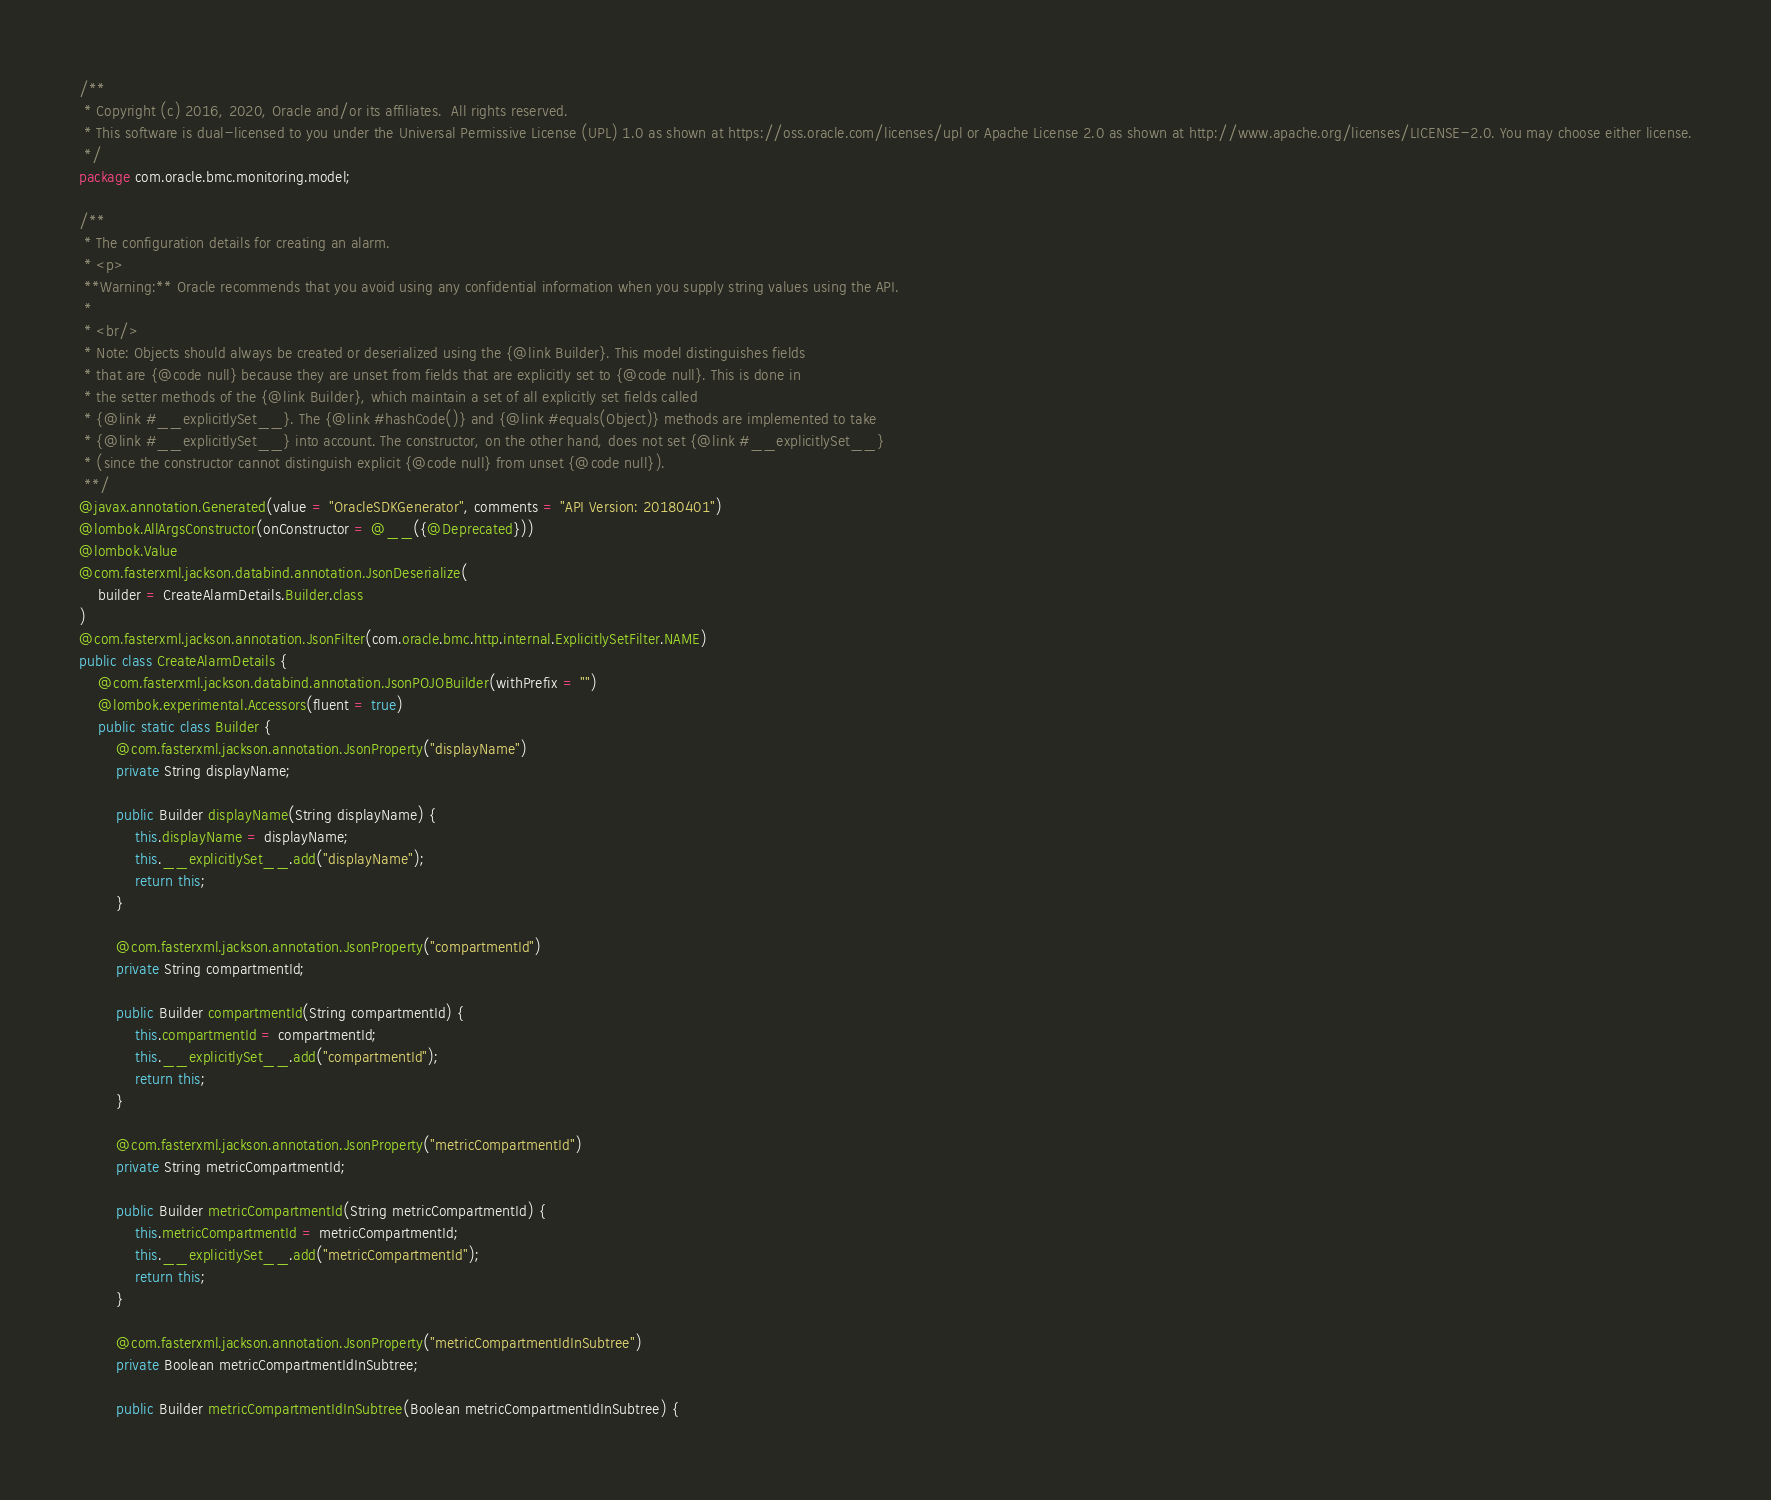Convert code to text. <code><loc_0><loc_0><loc_500><loc_500><_Java_>/**
 * Copyright (c) 2016, 2020, Oracle and/or its affiliates.  All rights reserved.
 * This software is dual-licensed to you under the Universal Permissive License (UPL) 1.0 as shown at https://oss.oracle.com/licenses/upl or Apache License 2.0 as shown at http://www.apache.org/licenses/LICENSE-2.0. You may choose either license.
 */
package com.oracle.bmc.monitoring.model;

/**
 * The configuration details for creating an alarm.
 * <p>
 **Warning:** Oracle recommends that you avoid using any confidential information when you supply string values using the API.
 *
 * <br/>
 * Note: Objects should always be created or deserialized using the {@link Builder}. This model distinguishes fields
 * that are {@code null} because they are unset from fields that are explicitly set to {@code null}. This is done in
 * the setter methods of the {@link Builder}, which maintain a set of all explicitly set fields called
 * {@link #__explicitlySet__}. The {@link #hashCode()} and {@link #equals(Object)} methods are implemented to take
 * {@link #__explicitlySet__} into account. The constructor, on the other hand, does not set {@link #__explicitlySet__}
 * (since the constructor cannot distinguish explicit {@code null} from unset {@code null}).
 **/
@javax.annotation.Generated(value = "OracleSDKGenerator", comments = "API Version: 20180401")
@lombok.AllArgsConstructor(onConstructor = @__({@Deprecated}))
@lombok.Value
@com.fasterxml.jackson.databind.annotation.JsonDeserialize(
    builder = CreateAlarmDetails.Builder.class
)
@com.fasterxml.jackson.annotation.JsonFilter(com.oracle.bmc.http.internal.ExplicitlySetFilter.NAME)
public class CreateAlarmDetails {
    @com.fasterxml.jackson.databind.annotation.JsonPOJOBuilder(withPrefix = "")
    @lombok.experimental.Accessors(fluent = true)
    public static class Builder {
        @com.fasterxml.jackson.annotation.JsonProperty("displayName")
        private String displayName;

        public Builder displayName(String displayName) {
            this.displayName = displayName;
            this.__explicitlySet__.add("displayName");
            return this;
        }

        @com.fasterxml.jackson.annotation.JsonProperty("compartmentId")
        private String compartmentId;

        public Builder compartmentId(String compartmentId) {
            this.compartmentId = compartmentId;
            this.__explicitlySet__.add("compartmentId");
            return this;
        }

        @com.fasterxml.jackson.annotation.JsonProperty("metricCompartmentId")
        private String metricCompartmentId;

        public Builder metricCompartmentId(String metricCompartmentId) {
            this.metricCompartmentId = metricCompartmentId;
            this.__explicitlySet__.add("metricCompartmentId");
            return this;
        }

        @com.fasterxml.jackson.annotation.JsonProperty("metricCompartmentIdInSubtree")
        private Boolean metricCompartmentIdInSubtree;

        public Builder metricCompartmentIdInSubtree(Boolean metricCompartmentIdInSubtree) {</code> 